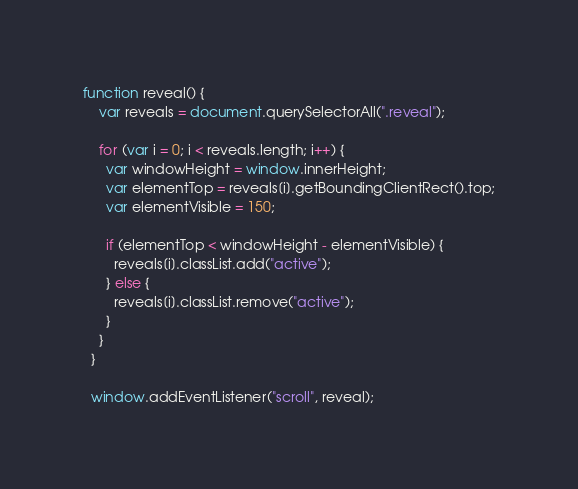<code> <loc_0><loc_0><loc_500><loc_500><_JavaScript_>function reveal() {
    var reveals = document.querySelectorAll(".reveal");
  
    for (var i = 0; i < reveals.length; i++) {
      var windowHeight = window.innerHeight;
      var elementTop = reveals[i].getBoundingClientRect().top;
      var elementVisible = 150;
  
      if (elementTop < windowHeight - elementVisible) {
        reveals[i].classList.add("active");
      } else {
        reveals[i].classList.remove("active");
      }
    }
  }
  
  window.addEventListener("scroll", reveal);</code> 